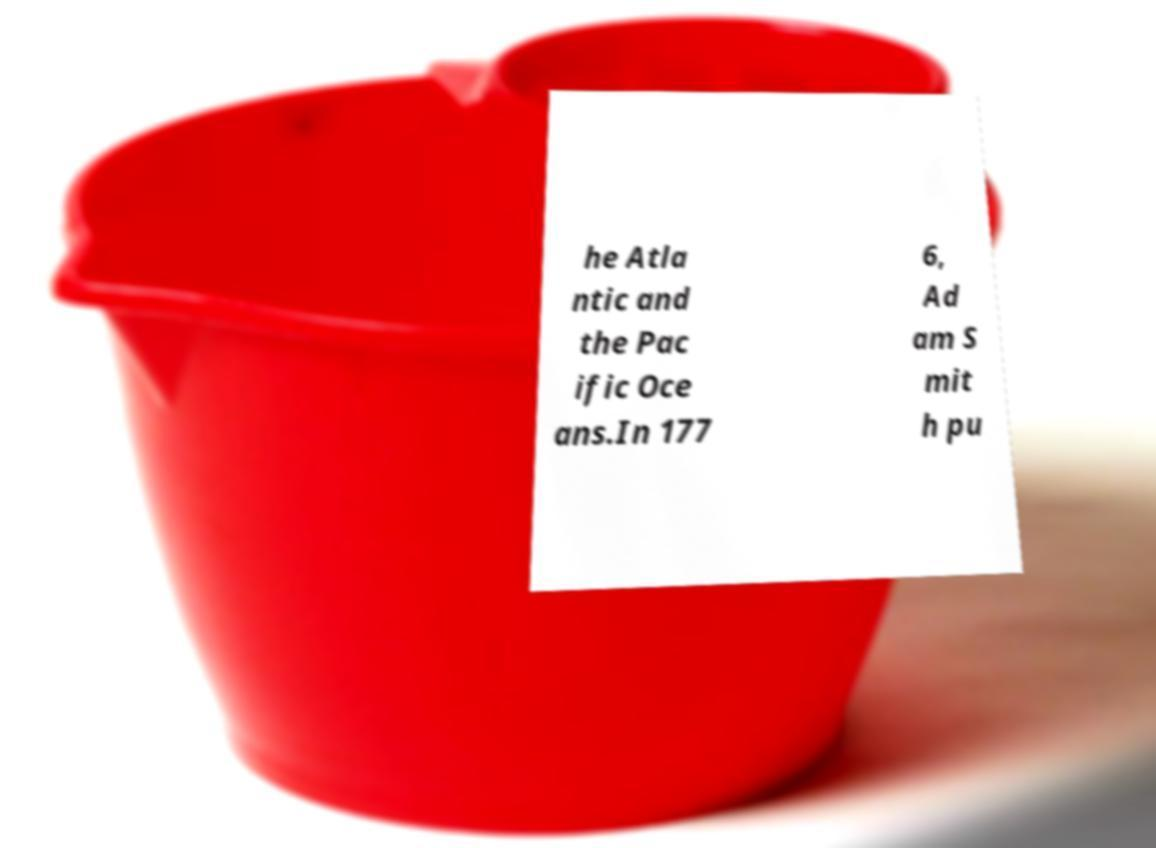Please identify and transcribe the text found in this image. he Atla ntic and the Pac ific Oce ans.In 177 6, Ad am S mit h pu 